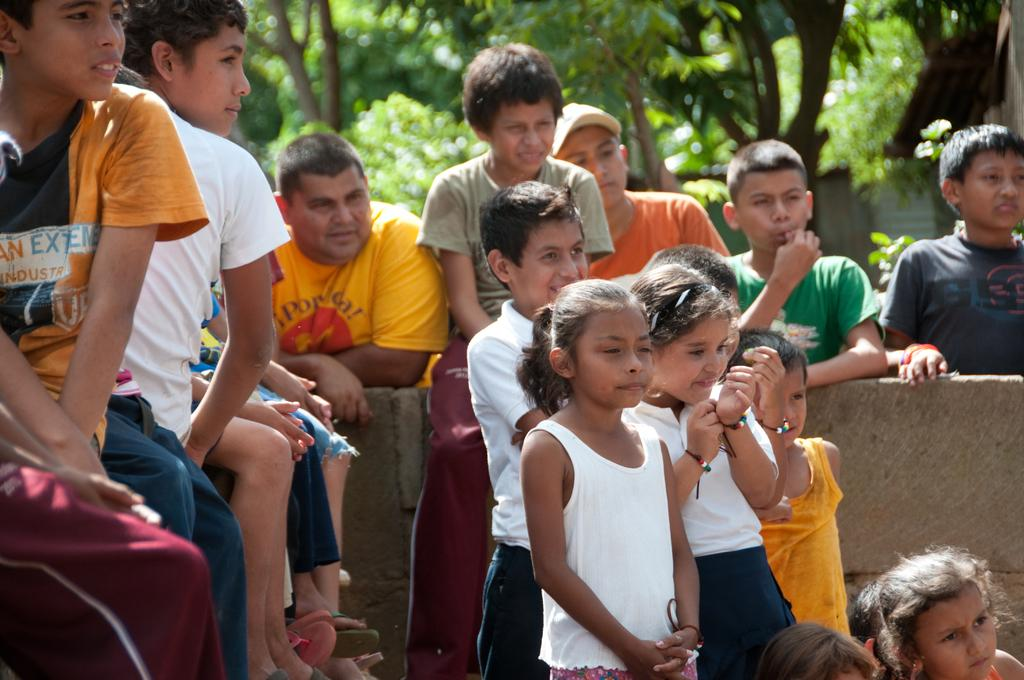What is the primary activity of the people in the image? The people in the image are either sitting or standing. Can you describe the positions of the people in the image? Some people are sitting, while others are standing. What is the background of the image? There is a wall in the image, and trees are visible behind the people. How many sponges can be seen in the image? There are no sponges present in the image. What is the development stage of the baby in the image? There is no baby present in the image. 